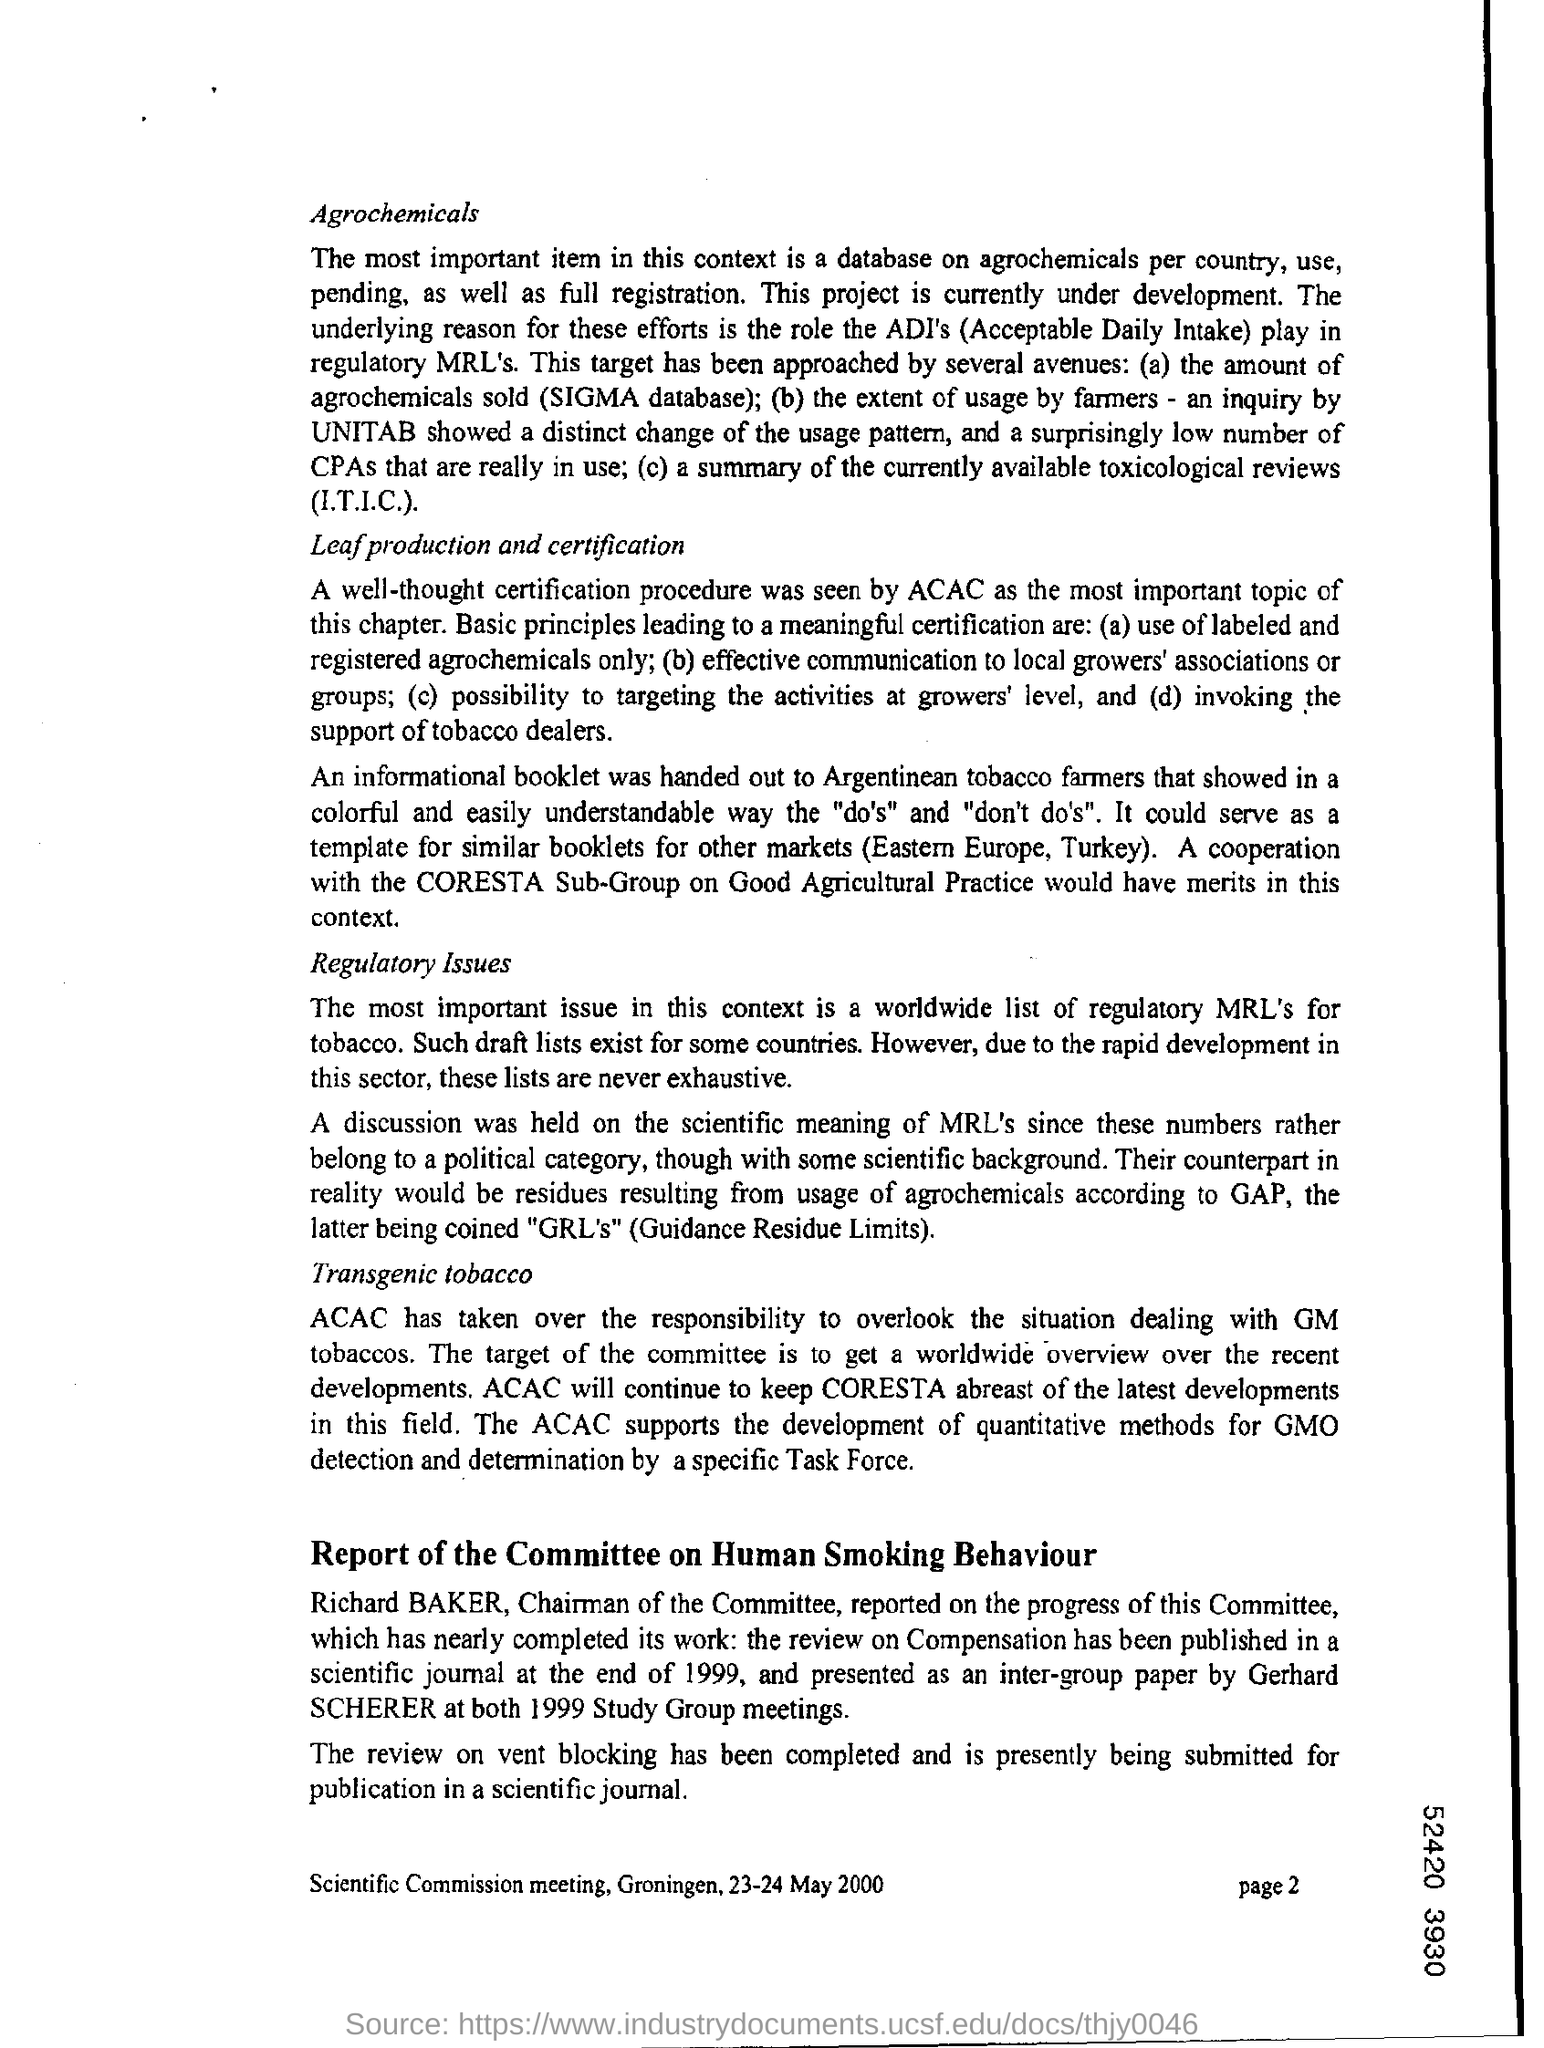Identify some key points in this picture. Mention the page number at the bottom right corner of the page, specifically page 2. The heading of the first paragraph from the top is 'Agrochemicals.' 